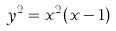<formula> <loc_0><loc_0><loc_500><loc_500>y ^ { 2 } = x ^ { 2 } ( x - 1 )</formula> 